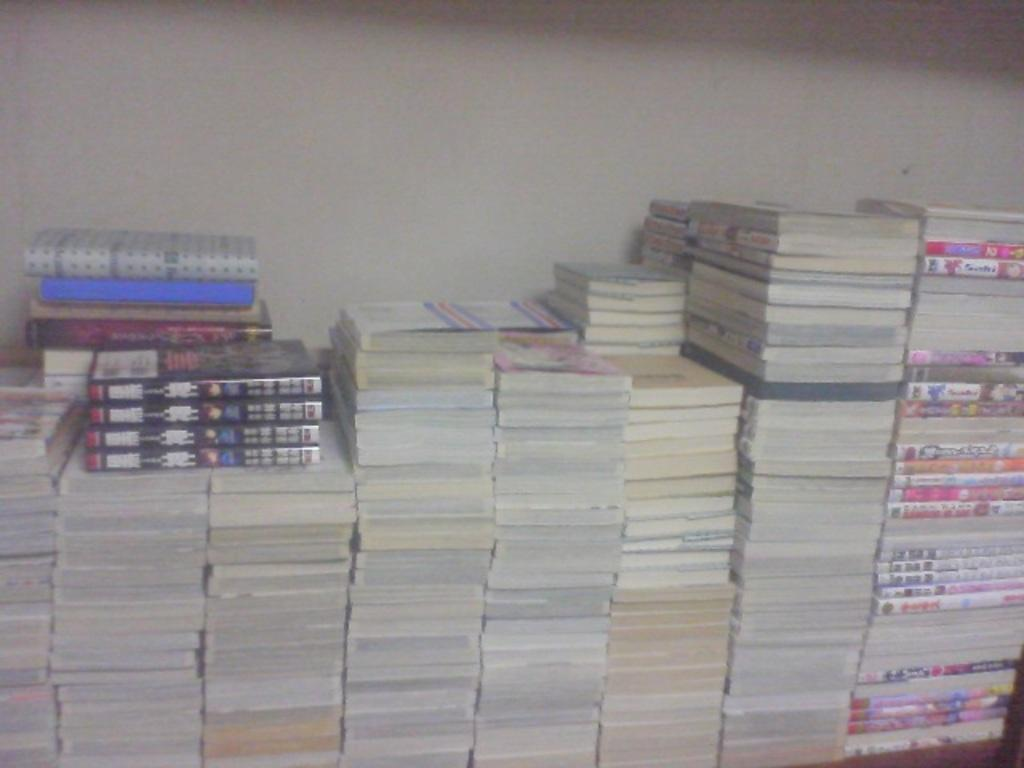What type of objects can be seen in the image? There are books in the image. Can you describe the books in more detail? Unfortunately, the image does not provide enough detail to describe the books further. How many books are visible in the image? The number of books cannot be determined from the image. Can you tell me how many goldfish are swimming in the bowl next to the books in the image? There is no bowl of goldfish present in the image; it only contains books. Is there any evidence of a brother in the image? The image does not provide any information about a brother or any other people. 